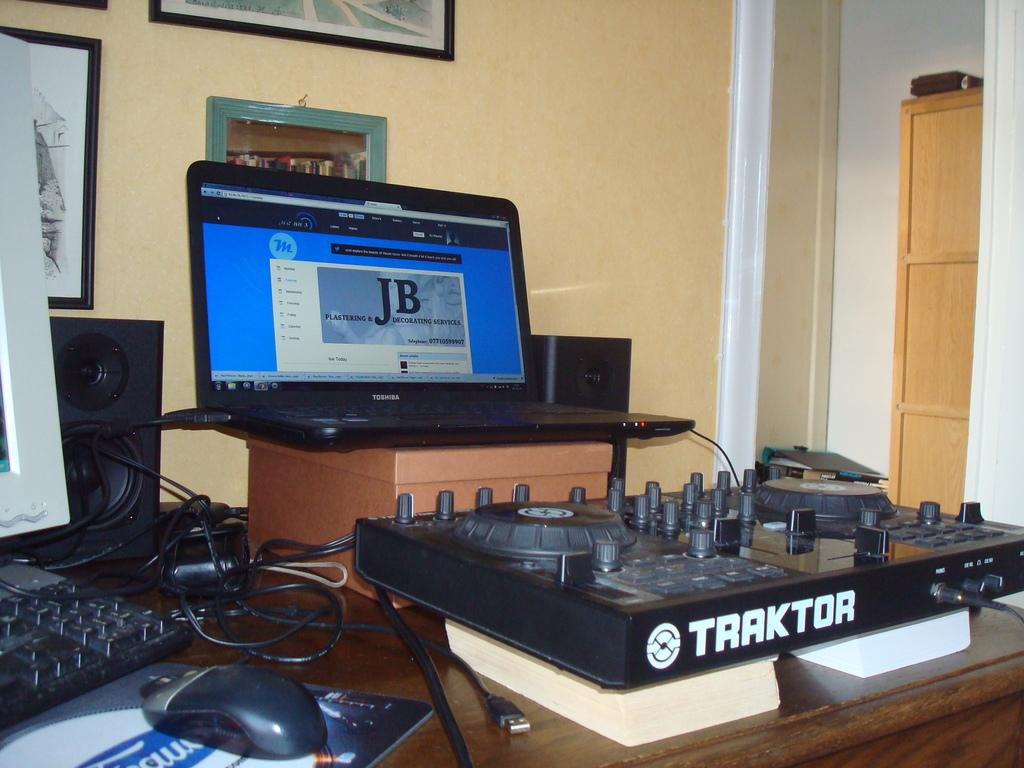<image>
Describe the image concisely. a computer open in front of a Traktor turn table 